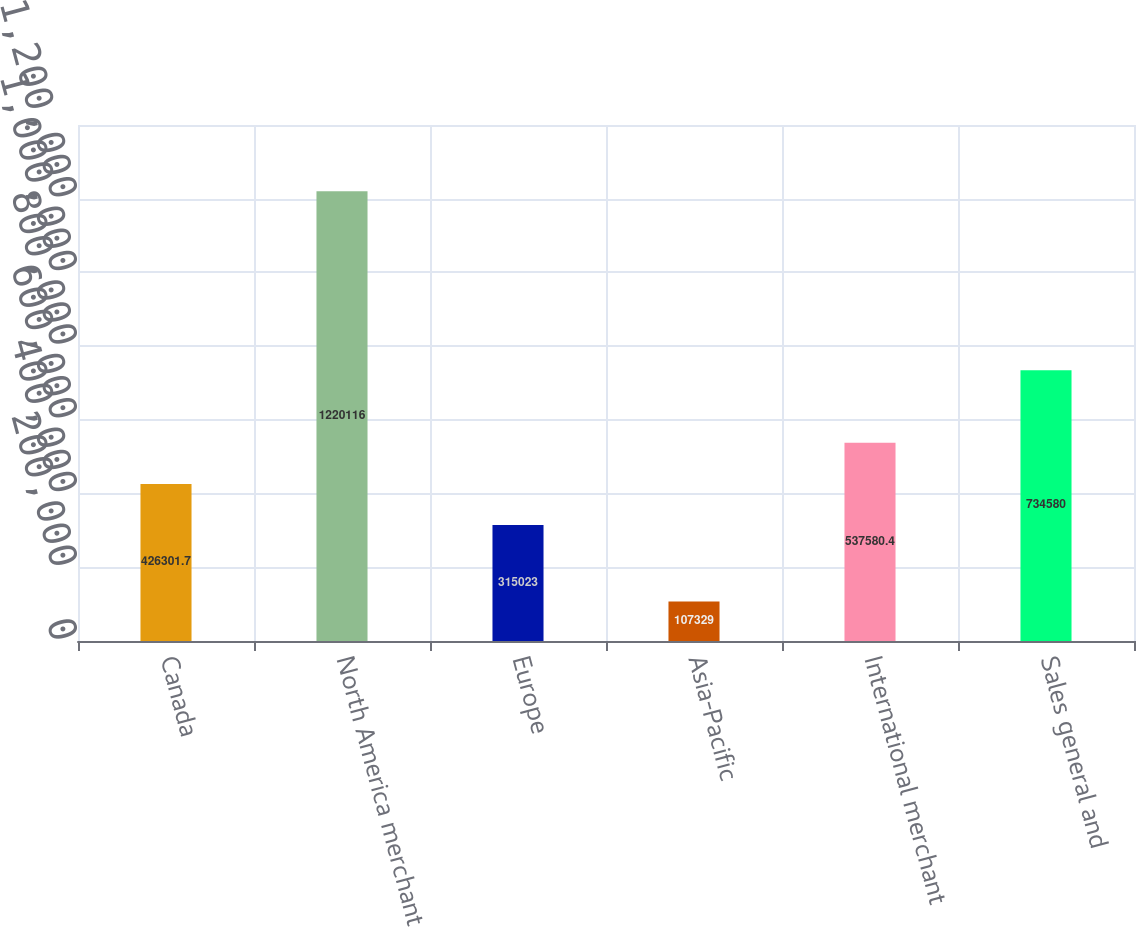<chart> <loc_0><loc_0><loc_500><loc_500><bar_chart><fcel>Canada<fcel>North America merchant<fcel>Europe<fcel>Asia-Pacific<fcel>International merchant<fcel>Sales general and<nl><fcel>426302<fcel>1.22012e+06<fcel>315023<fcel>107329<fcel>537580<fcel>734580<nl></chart> 